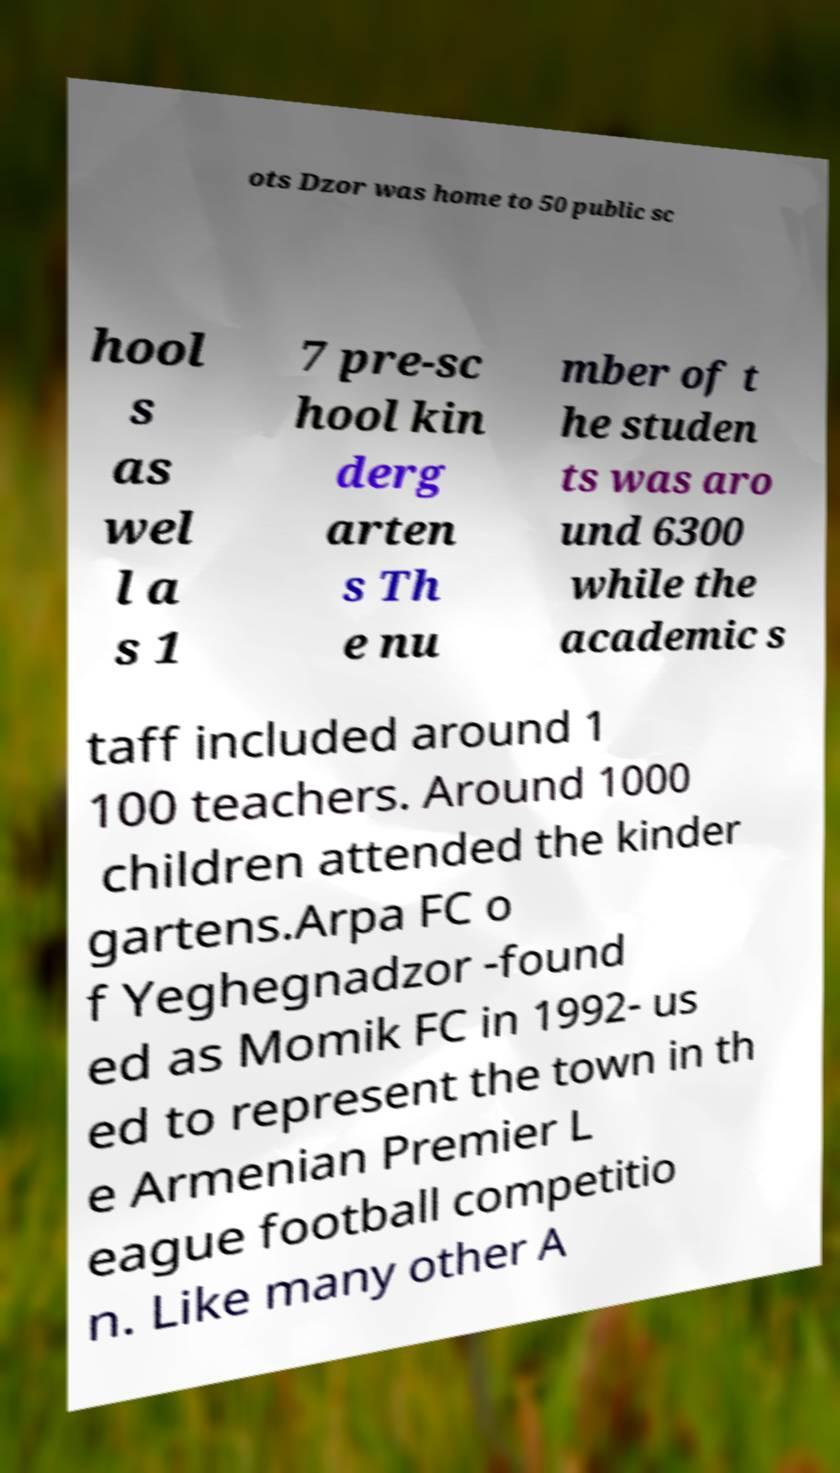Could you assist in decoding the text presented in this image and type it out clearly? ots Dzor was home to 50 public sc hool s as wel l a s 1 7 pre-sc hool kin derg arten s Th e nu mber of t he studen ts was aro und 6300 while the academic s taff included around 1 100 teachers. Around 1000 children attended the kinder gartens.Arpa FC o f Yeghegnadzor -found ed as Momik FC in 1992- us ed to represent the town in th e Armenian Premier L eague football competitio n. Like many other A 